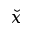Convert formula to latex. <formula><loc_0><loc_0><loc_500><loc_500>\check { x }</formula> 